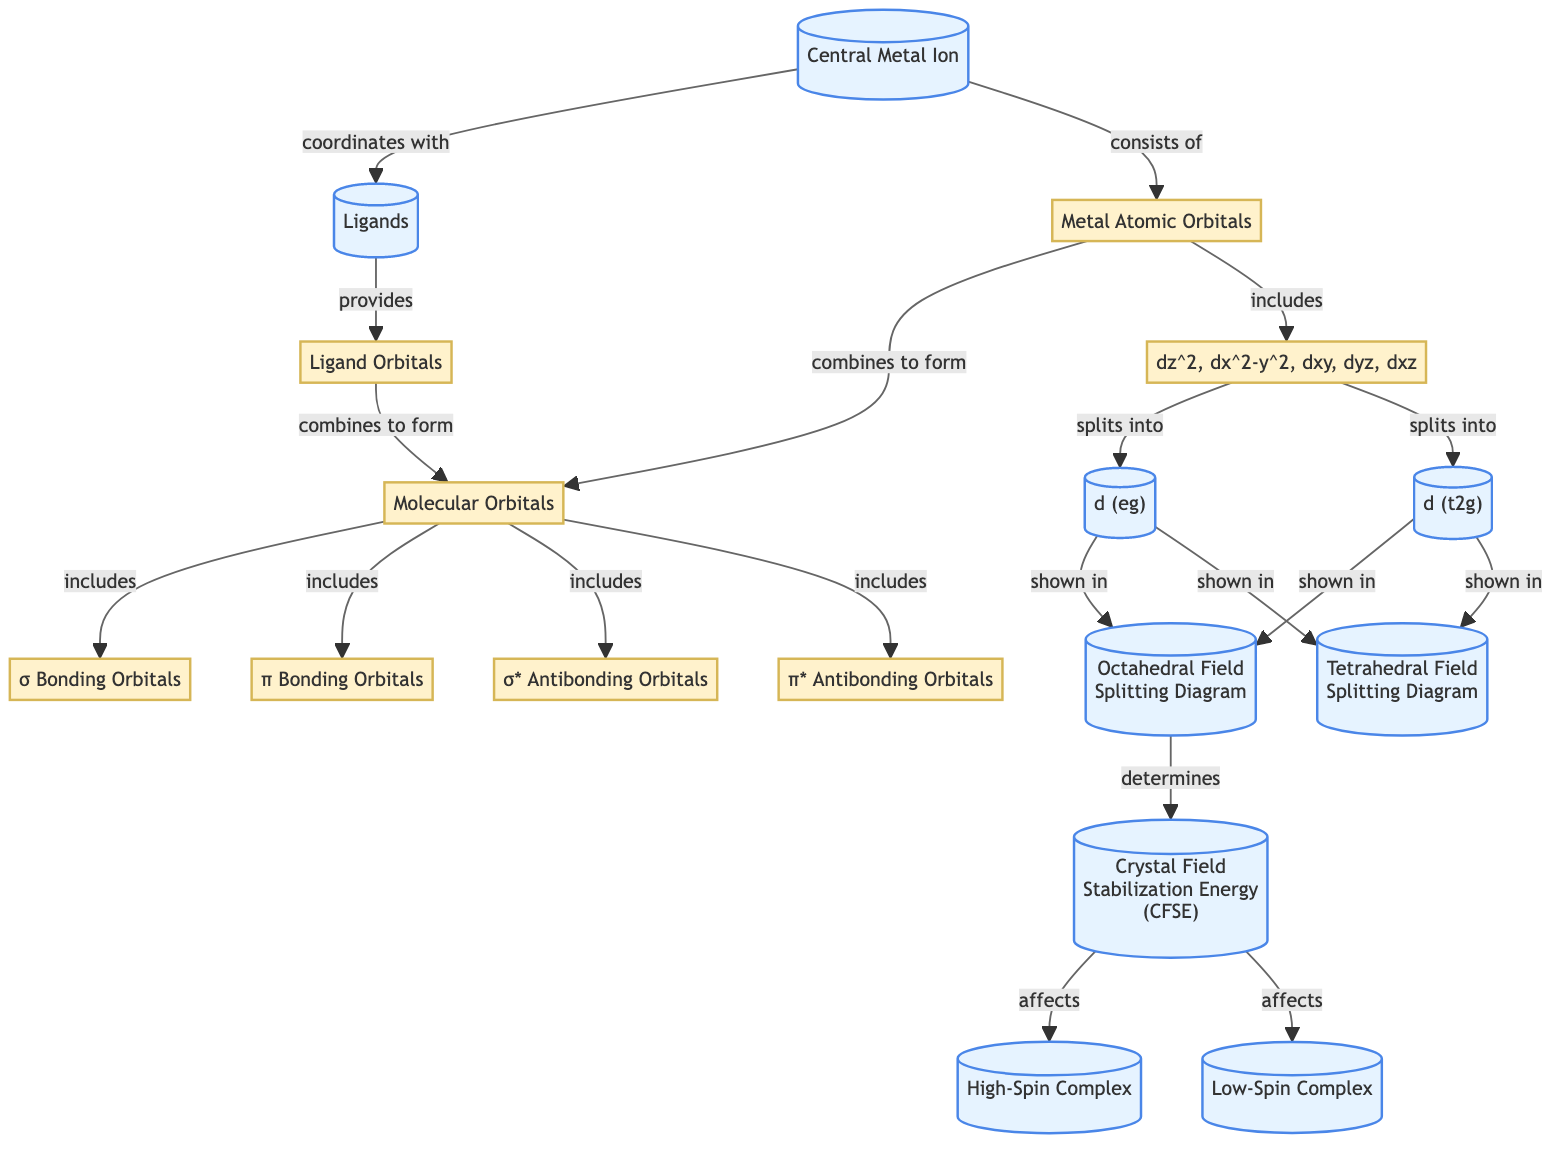What is the central component at the top of the diagram? The diagram identifies the "Central Metal Ion" as the primary focus at the top. This is confirmed by following the path originating from the central node labeled "Central Metal Ion", which is the foundational element around which the entire diagram is structured.
Answer: Central Metal Ion How many types of splitting diagrams are depicted in the diagram? By examining the diagram, we can identify two splitting diagrams listed as "Octahedral Field Splitting Diagram" and "Tetrahedral Field Splitting Diagram". Thus, these two nodes confirm that there are two types depicted.
Answer: 2 What do the d-orbitals split into in an octahedral field? The d-orbitals split into two groups: "d (eg)" and "d (t2g)". This is shown directly in the diagram where the node for the d-orbitals (from the "Metal Atomic Orbitals" section) identifies and branches out into these two distinct sets of orbitals.
Answer: d (eg) and d (t2g) What does the Crystal Field Stabilization Energy relate to in the diagram? In the diagram, the "Crystal Field Stabilization Energy (CFSE)" is influenced by the "Octahedral Field Splitting Diagram" and "Tetrahedral Field Splitting Diagram", as indicated by the arrows leading to this node. This shows that CFSE fundamentally relates to the splitting of the d-orbitals based on field geometry.
Answer: Octahedral and Tetrahedral Field Splitting Which type of complex is affected by Crystal Field Stabilization Energy? The diagram indicates that both "High-Spin Complex" and "Low-Spin Complex" are affected by the Crystal Field Stabilization Energy. This is evident from the connections leading from the CFSE node to these two types of complexes, demonstrating that CFSE has implications for both categories.
Answer: High-Spin Complex and Low-Spin Complex 